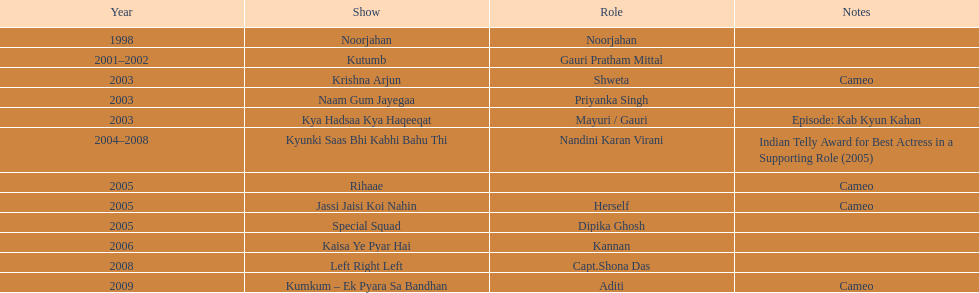Which show featured gauri for the greatest length of time? Kyunki Saas Bhi Kabhi Bahu Thi. 